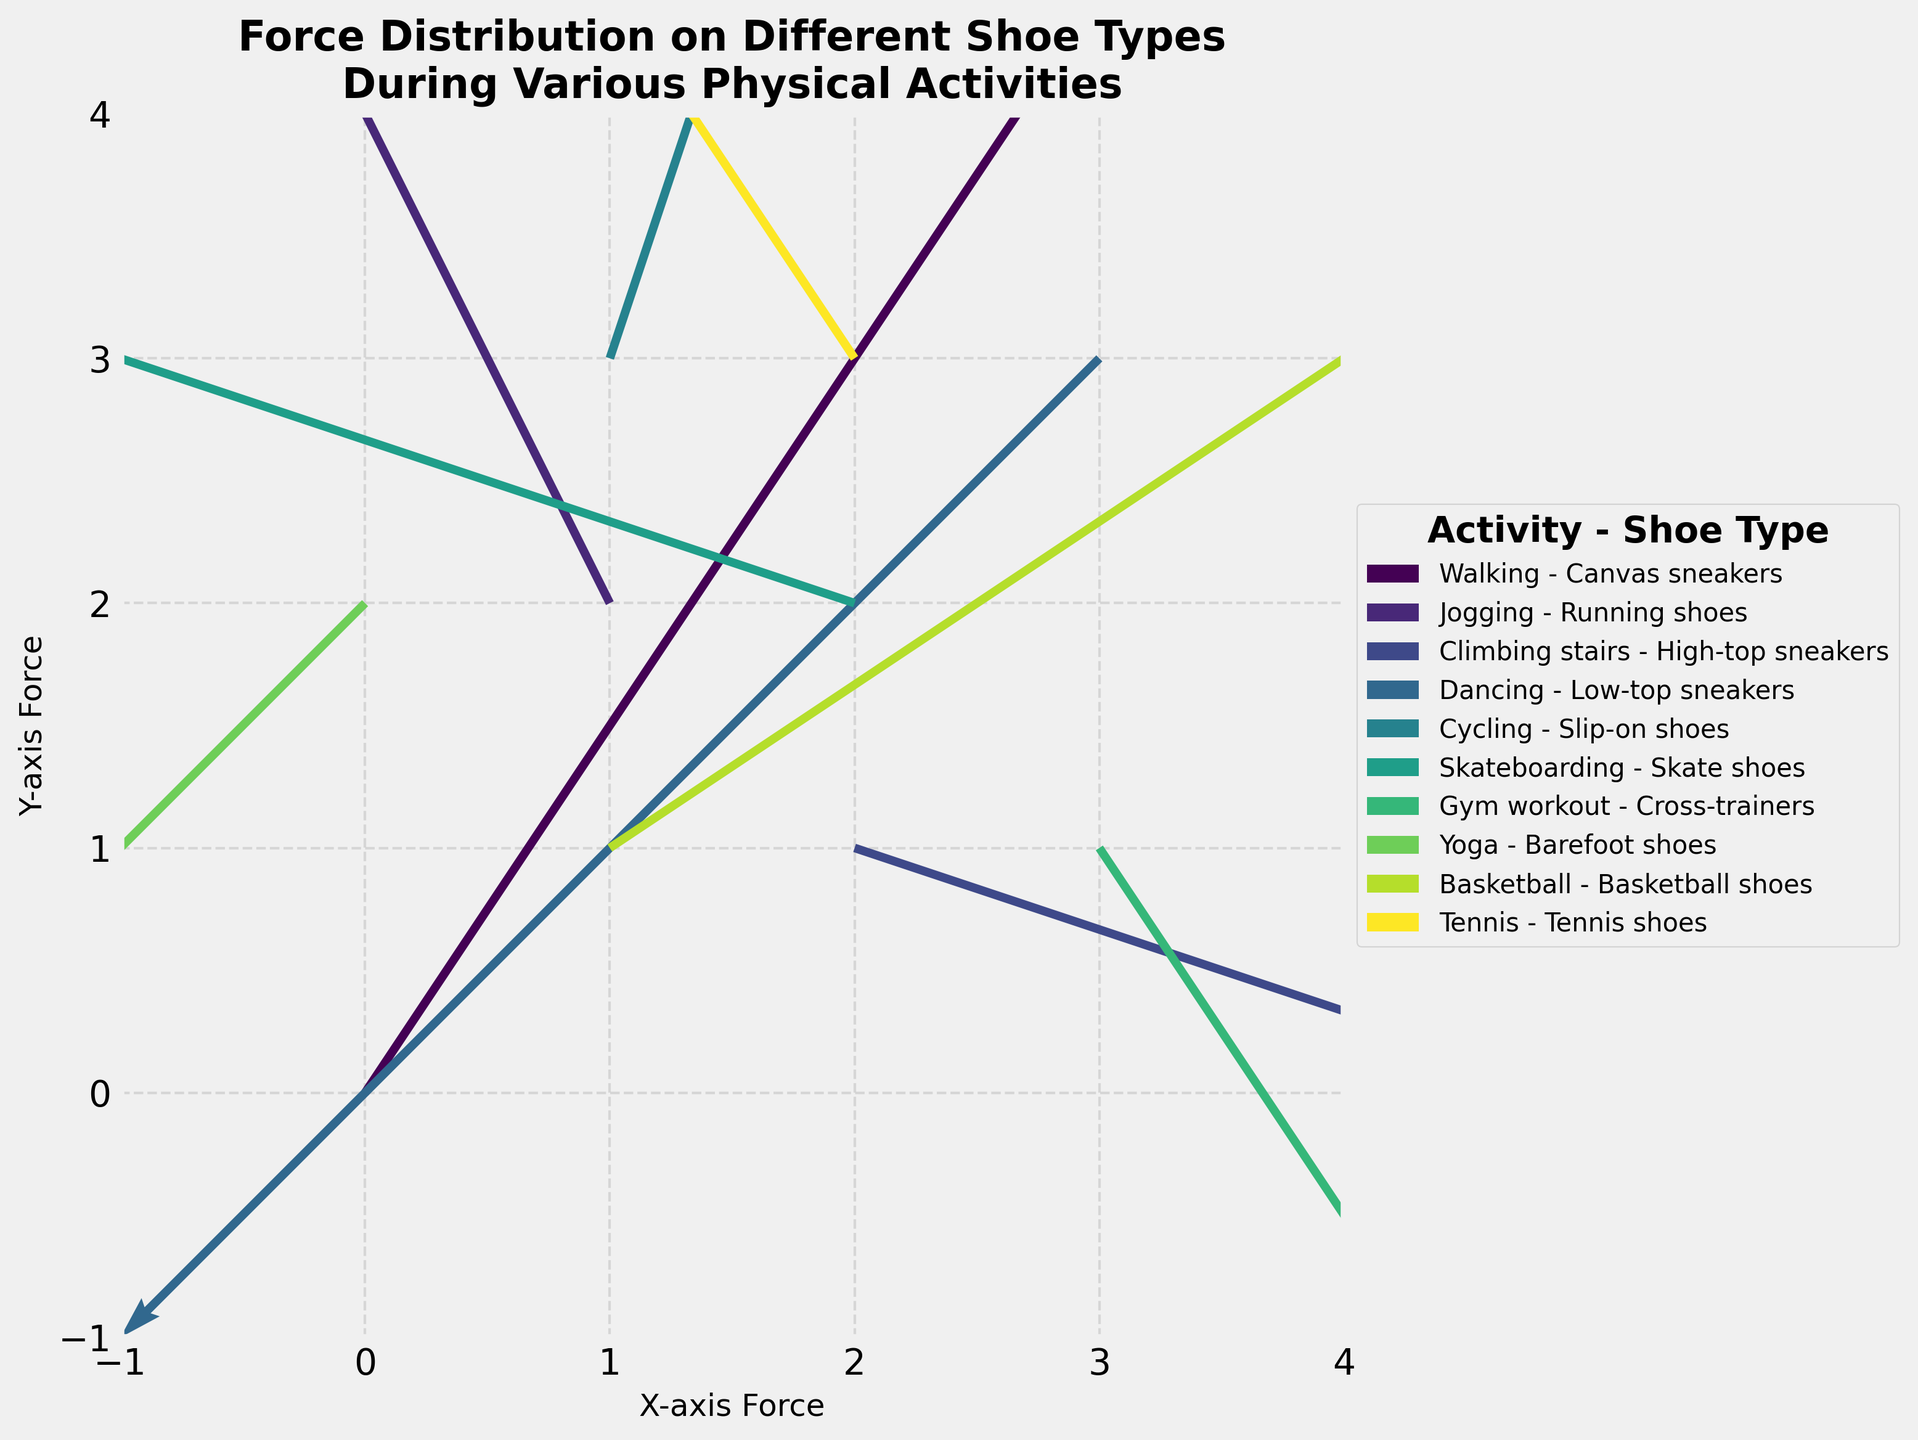What's the title of the figure? The title is usually displayed at the top of the figure. It describes the purpose or the main idea of the figure.
Answer: "Force Distribution on Different Shoe Types During Various Physical Activities" What are the labels of the x-axis and y-axis? The axis labels are usually found next to the respective axes and describe what each axis represents.
Answer: x-axis: "X-axis Force", y-axis: "Y-axis Force" How many different physical activities are depicted in the figure? By looking at the legend, which lists all the physical activities, you can count the number of unique activities listed.
Answer: 10 Which shoe type experiences the highest upward y-axis force? To determine this, we need to look for the arrow (quiver) pointing most upwards (highest positive y-component) and check the corresponding shoe type from the legend. "Basketball shoes" has the arrow with the highest positive y-component.
Answer: Basketball shoes What range is used for the x-axis and y-axis in the plot? Check the axis limits displayed on the plot to determine the range used for both axes.
Answer: x-axis: -1 to 4, y-axis: -1 to 4 Which activity-shoe combination experiences the largest negative x-axis force? Locate the arrow with the largest leftward (negative x-axis) direction and refer to the legend for the activity and shoe type. "Skateboarding - Skate shoes" has the largest negative x-component.
Answer: Skateboarding - Skate shoes How does the force distribution of 'Yoga - Barefoot shoes' compare with 'Gym workout - Cross-trainers'? Compare the length and direction of the arrows representing 'Yoga - Barefoot shoes' and 'Gym workout - Cross-trainers'. "Yoga - Barefoot shoes" has a smaller magnitude of force in the negative direction compared to "Gym workout - Cross-trainers", which has a larger downward and rightward force.
Answer: Yoga - Barefoot shoes has less force, more toward the origin What's the average x-direction force for 'Tennis - Tennis shoes' and 'Dancing - Low-top sneakers'? To find the average x-direction force, sum up the x-components of both activities and divide by the number of activities: (-2 + (-2)) / 2 = -2
Answer: -2 Which shoe type shows a force distribution most similar to 'Running shoes' during 'Jogging'? Examine the direction and length of arrows similar to 'Running shoes' during 'Jogging' by looking for nearby arrows with similar vectors in the quiver plot. "Tennis shoes" during "Tennis" has a similar direction and magnitude.
Answer: Tennis shoes during Tennis 